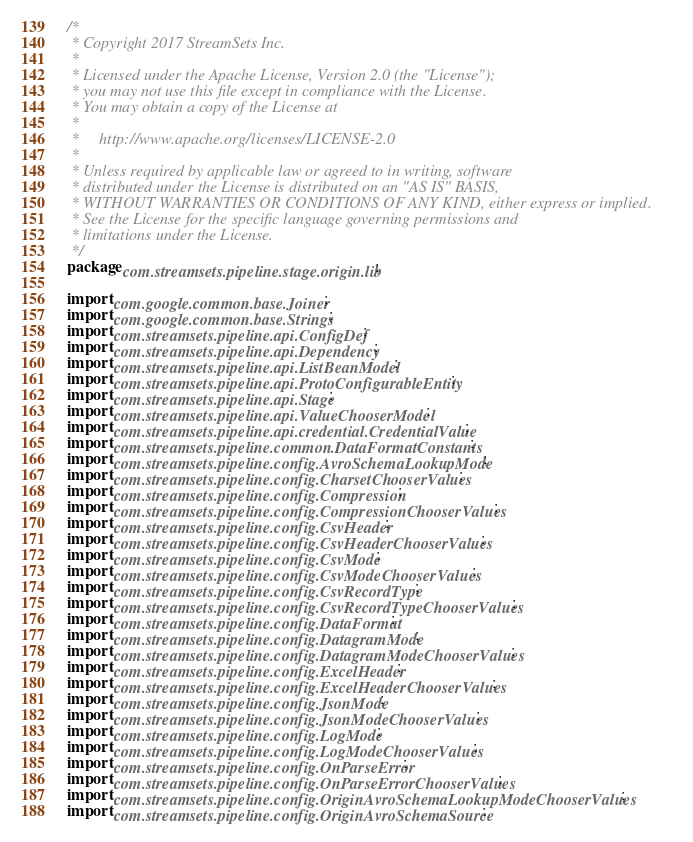<code> <loc_0><loc_0><loc_500><loc_500><_Java_>/*
 * Copyright 2017 StreamSets Inc.
 *
 * Licensed under the Apache License, Version 2.0 (the "License");
 * you may not use this file except in compliance with the License.
 * You may obtain a copy of the License at
 *
 *     http://www.apache.org/licenses/LICENSE-2.0
 *
 * Unless required by applicable law or agreed to in writing, software
 * distributed under the License is distributed on an "AS IS" BASIS,
 * WITHOUT WARRANTIES OR CONDITIONS OF ANY KIND, either express or implied.
 * See the License for the specific language governing permissions and
 * limitations under the License.
 */
package com.streamsets.pipeline.stage.origin.lib;

import com.google.common.base.Joiner;
import com.google.common.base.Strings;
import com.streamsets.pipeline.api.ConfigDef;
import com.streamsets.pipeline.api.Dependency;
import com.streamsets.pipeline.api.ListBeanModel;
import com.streamsets.pipeline.api.ProtoConfigurableEntity;
import com.streamsets.pipeline.api.Stage;
import com.streamsets.pipeline.api.ValueChooserModel;
import com.streamsets.pipeline.api.credential.CredentialValue;
import com.streamsets.pipeline.common.DataFormatConstants;
import com.streamsets.pipeline.config.AvroSchemaLookupMode;
import com.streamsets.pipeline.config.CharsetChooserValues;
import com.streamsets.pipeline.config.Compression;
import com.streamsets.pipeline.config.CompressionChooserValues;
import com.streamsets.pipeline.config.CsvHeader;
import com.streamsets.pipeline.config.CsvHeaderChooserValues;
import com.streamsets.pipeline.config.CsvMode;
import com.streamsets.pipeline.config.CsvModeChooserValues;
import com.streamsets.pipeline.config.CsvRecordType;
import com.streamsets.pipeline.config.CsvRecordTypeChooserValues;
import com.streamsets.pipeline.config.DataFormat;
import com.streamsets.pipeline.config.DatagramMode;
import com.streamsets.pipeline.config.DatagramModeChooserValues;
import com.streamsets.pipeline.config.ExcelHeader;
import com.streamsets.pipeline.config.ExcelHeaderChooserValues;
import com.streamsets.pipeline.config.JsonMode;
import com.streamsets.pipeline.config.JsonModeChooserValues;
import com.streamsets.pipeline.config.LogMode;
import com.streamsets.pipeline.config.LogModeChooserValues;
import com.streamsets.pipeline.config.OnParseError;
import com.streamsets.pipeline.config.OnParseErrorChooserValues;
import com.streamsets.pipeline.config.OriginAvroSchemaLookupModeChooserValues;
import com.streamsets.pipeline.config.OriginAvroSchemaSource;</code> 